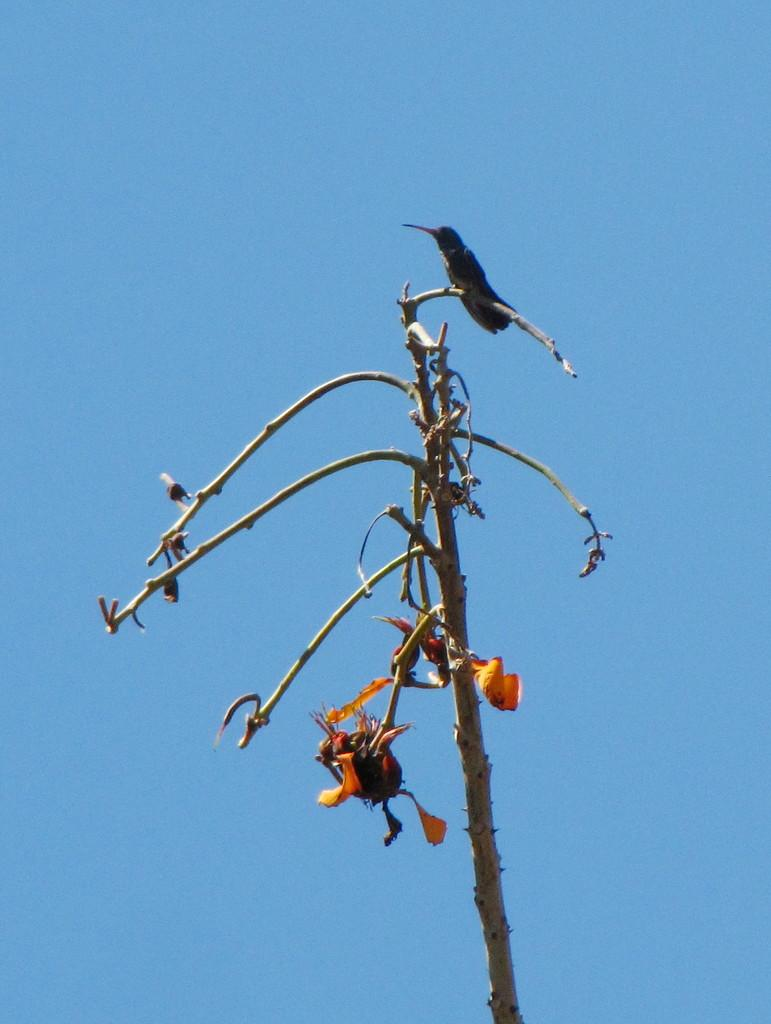What type of animal can be seen in the image? There is a bird in the image. Where is the bird located? The bird is on a branch. What other object can be seen in the image? There is a yellow flower in the image. What color is the sky in the image? The sky is blue in color. What type of popcorn is being used to create the plot in the image? There is no popcorn or plot present in the image; it features a bird on a branch and a yellow flower. 